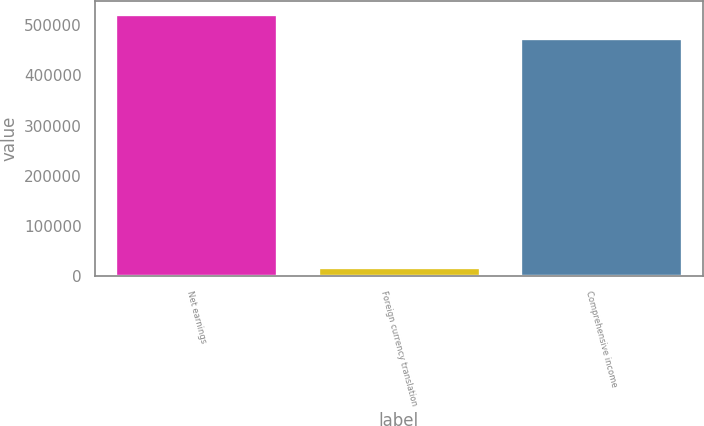Convert chart. <chart><loc_0><loc_0><loc_500><loc_500><bar_chart><fcel>Net earnings<fcel>Foreign currency translation<fcel>Comprehensive income<nl><fcel>522760<fcel>18683<fcel>475213<nl></chart> 